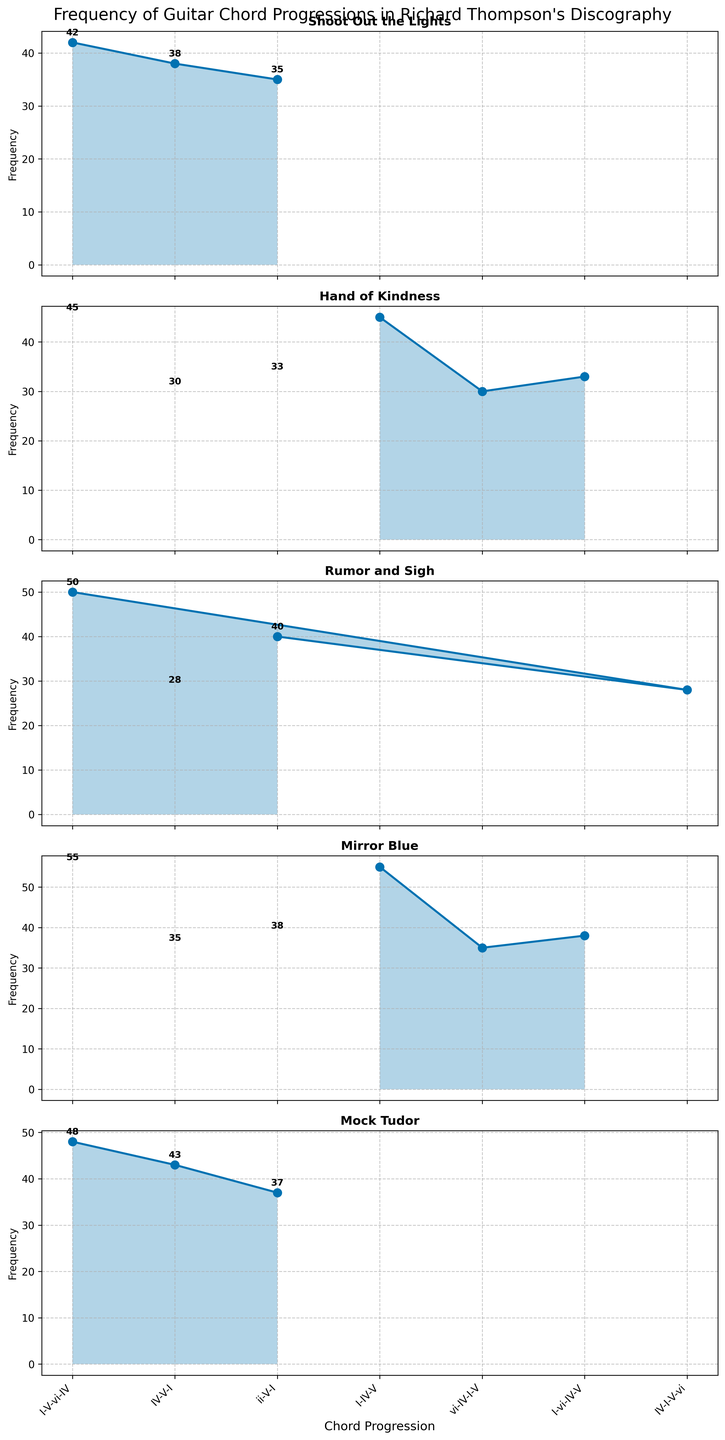What is the title of the figure? The title is located at the top center of the figure and is typically formatted in a larger and bold font.
Answer: Frequency of Guitar Chord Progressions in Richard Thompson's Discography How many subplots are there in the figure? The figure contains the same number of subplots as there are unique albums, which appears as separate plots stacked vertically.
Answer: 4 Which album has the highest frequency of the chord progression I-IV-V? By looking at the subplot for each album, identify the one where the I-IV-V chord progression has the highest frequency value.
Answer: Mirror Blue What is the total frequency of the chord progression I-V-vi-IV across all albums? Add the frequencies of the I-V-vi-IV chord progression for all albums: 42 + 50 + 48
Answer: 140 Which chord progression is the least frequent in the album "Hand of Kindness"? In the subplot for "Hand of Kindness", identify the chord progression with the smallest numerical value for the frequency.
Answer: vi-IV-I-V Which album shows an increasing pattern in chord progression frequencies from left to right? Look for an album where the points on the subplot form an upward slope.
Answer: Not available (None show a consistent increasing pattern) Compare the frequency of the chord progression ii-V-I in "Shoot Out the Lights" and "Rumor and Sigh". Which one is higher and by how much? Compare the value of ii-V-I in each subplot for these two albums: 35 (Shoot Out the Lights) and 40 (Rumor and Sigh). Subtract the smaller value from the larger value.
Answer: Rumor and Sigh by 5 